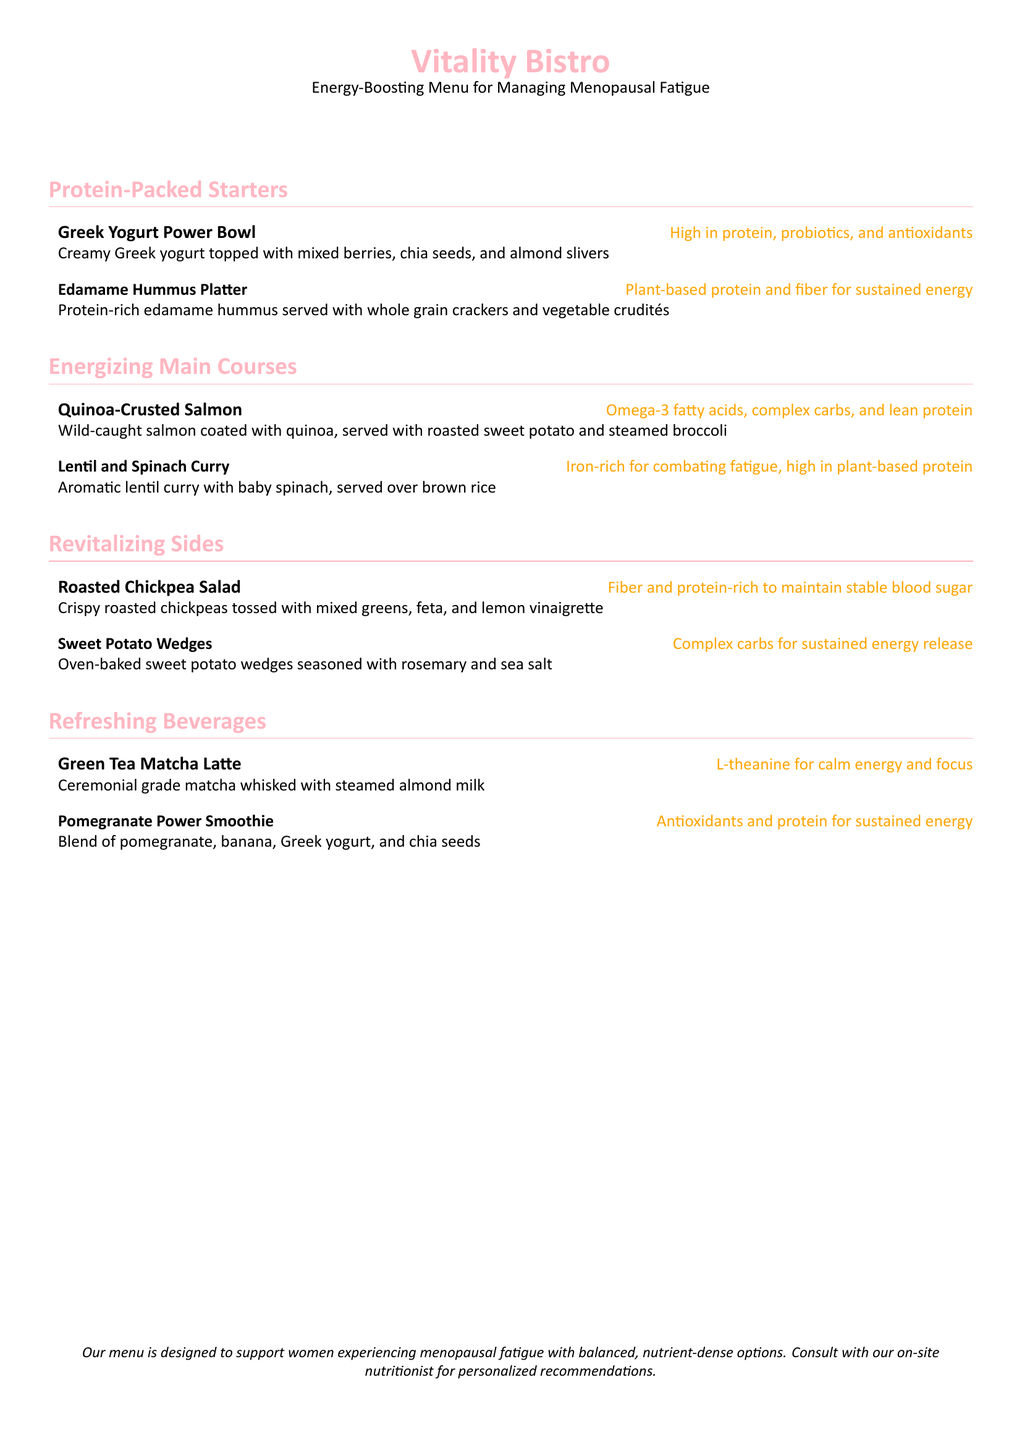What are the two protein-packed starters on the menu? The two protein-packed starters listed are "Greek Yogurt Power Bowl" and "Edamame Hummus Platter."
Answer: Greek Yogurt Power Bowl, Edamame Hummus Platter What are the main components of the Quinoa-Crusted Salmon dish? The main components are wild-caught salmon, quinoa coating, roasted sweet potato, and steamed broccoli.
Answer: Wild-caught salmon, quinoa, roasted sweet potato, steamed broccoli How many energizing main courses are offered on the menu? The document lists two energizing main courses: "Quinoa-Crusted Salmon" and "Lentil and Spinach Curry."
Answer: Two What is included in the Roasted Chickpea Salad? The salad consists of crispy roasted chickpeas, mixed greens, feta, and lemon vinaigrette.
Answer: Crispy roasted chickpeas, mixed greens, feta, lemon vinaigrette What type of drink is the Green Tea Matcha Latte? It is a drink made with ceremonial grade matcha whisked with steamed almond milk.
Answer: Matcha with steamed almond milk What benefit is mentioned for the Pomegranate Power Smoothie? The smoothie is noted for providing antioxidants and protein for sustained energy.
Answer: Antioxidants and protein Which side dish provides complex carbohydrates? The Sweet Potato Wedges dish is recognized for providing complex carbohydrates.
Answer: Sweet Potato Wedges Who should a guest consult for personalized recommendations? Guests are encouraged to consult with the on-site nutritionist for personalized recommendations.
Answer: On-site nutritionist 